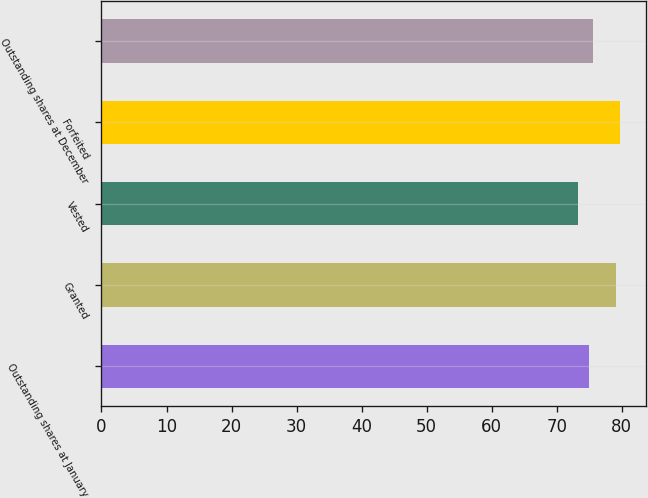<chart> <loc_0><loc_0><loc_500><loc_500><bar_chart><fcel>Outstanding shares at January<fcel>Granted<fcel>Vested<fcel>Forfeited<fcel>Outstanding shares at December<nl><fcel>74.94<fcel>79.1<fcel>73.22<fcel>79.75<fcel>75.59<nl></chart> 